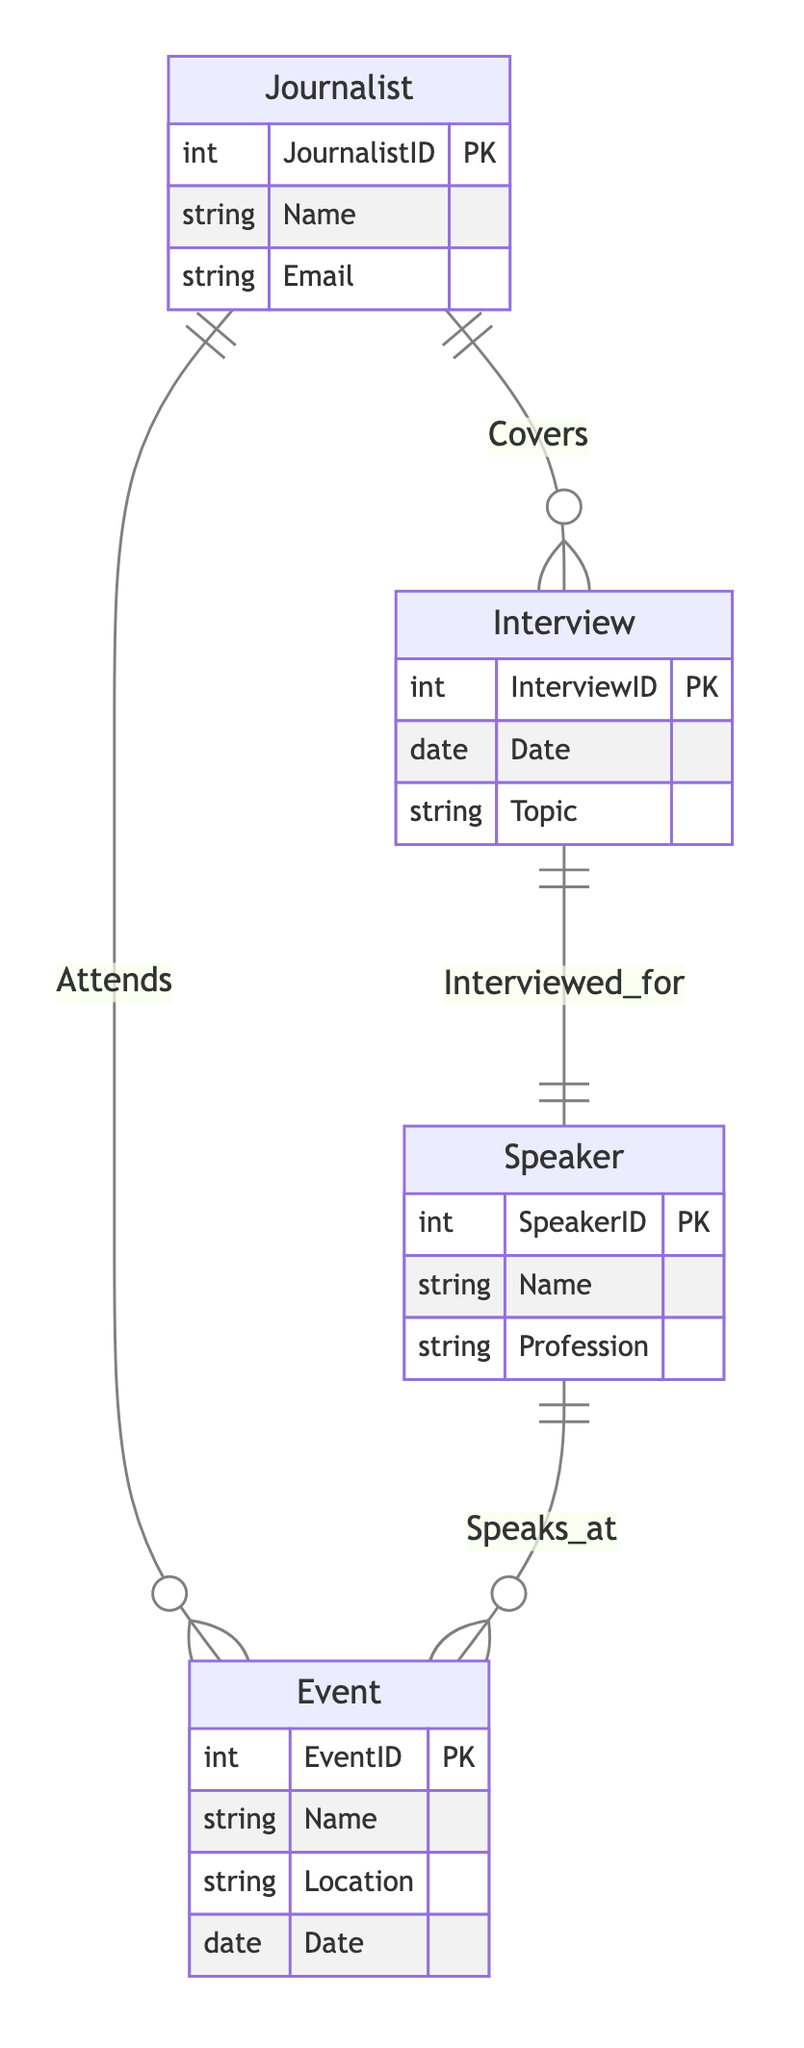What is the primary key of the Journalist entity? The primary key of the Journalist entity is JournalistID, which uniquely identifies each journalist in the database.
Answer: JournalistID How many attributes does the Event entity have? The Event entity has four attributes: EventID, Name, Location, and Date. Therefore, the count of attributes is four.
Answer: Four What relationship connects the Journalist and Event entities? The relationship that connects the Journalist and Event entities is called "Attends," indicating that a journalist can attend events.
Answer: Attends What is the primary key of the Interview entity? The primary key of the Interview entity is InterviewID, which serves to uniquely identify each interview record in the system.
Answer: InterviewID Which entity represents speakers at events? The entity that represents speakers at events is the Speaker entity, as it is designated to include individuals who speak at various events.
Answer: Speaker How many entities are present in the diagram? The diagram contains four distinct entities: Journalist, Interview, Event, and Speaker, leading to a total count of four entities.
Answer: Four What is the relationship between Interview and Speaker entities? The relationship between the Interview and Speaker entities is "Interviewed_for," indicating that a speaker can be a subject of an interview.
Answer: Interviewed_for What role does the Journalist play in the relationship with Interview? In the relationship with Interview, the Journalist plays the role of "covers," meaning they cover or report on the interviews.
Answer: Covers Who can attend events according to the diagram? According to the diagram, journalists can attend events as indicated by the "Attends" relationship linking them to the Event entity.
Answer: Journalists 